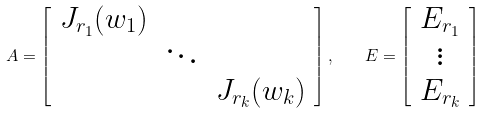<formula> <loc_0><loc_0><loc_500><loc_500>A = \left [ \begin{array} { c c c } J _ { r _ { 1 } } ( w _ { 1 } ) & & \\ & \ddots & \\ & & J _ { r _ { k } } ( w _ { k } ) \end{array} \right ] , \quad E = \left [ \begin{array} { c } E _ { r _ { 1 } } \\ \vdots \\ E _ { r _ { k } } \end{array} \right ]</formula> 